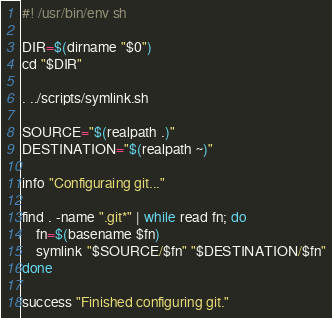<code> <loc_0><loc_0><loc_500><loc_500><_Bash_>#! /usr/bin/env sh

DIR=$(dirname "$0")
cd "$DIR"

. ../scripts/symlink.sh

SOURCE="$(realpath .)"
DESTINATION="$(realpath ~)"

info "Configuraing git..."

find . -name ".git*" | while read fn; do
    fn=$(basename $fn)
    symlink "$SOURCE/$fn" "$DESTINATION/$fn"
done

success "Finished configuring git."
</code> 